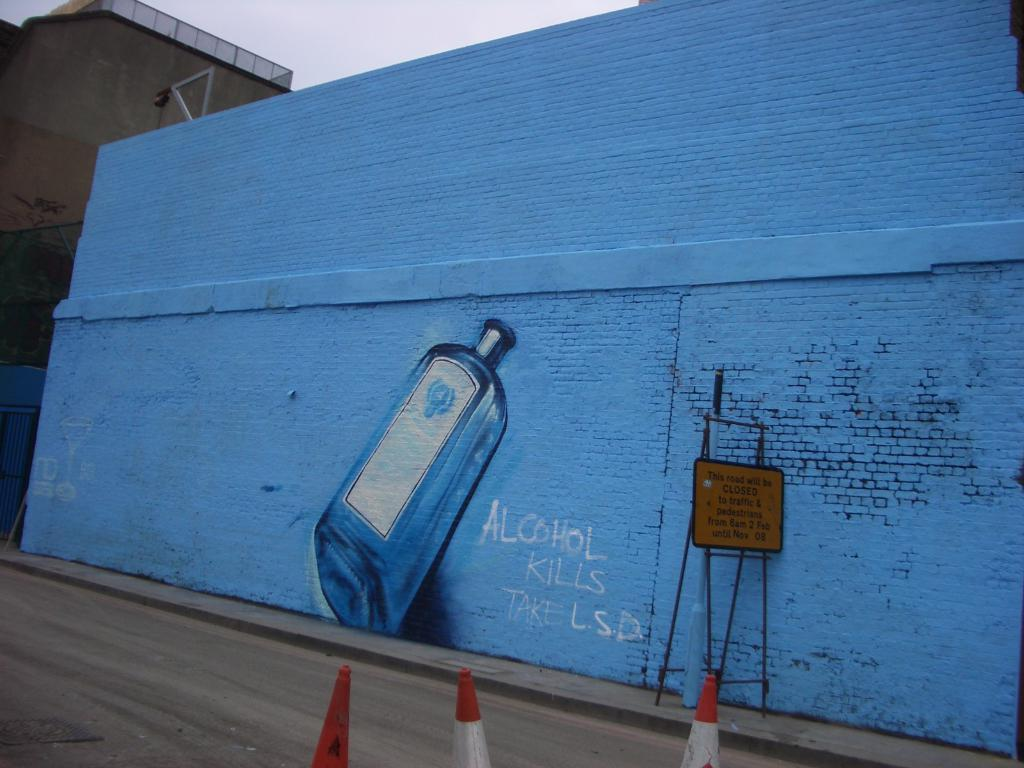<image>
Describe the image concisely. The graphiti says alcohol kills and to instead take LSD 